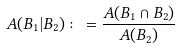Convert formula to latex. <formula><loc_0><loc_0><loc_500><loc_500>A ( B _ { 1 } | B _ { 2 } ) \colon = \frac { A ( B _ { 1 } \cap B _ { 2 } ) } { A ( B _ { 2 } ) }</formula> 